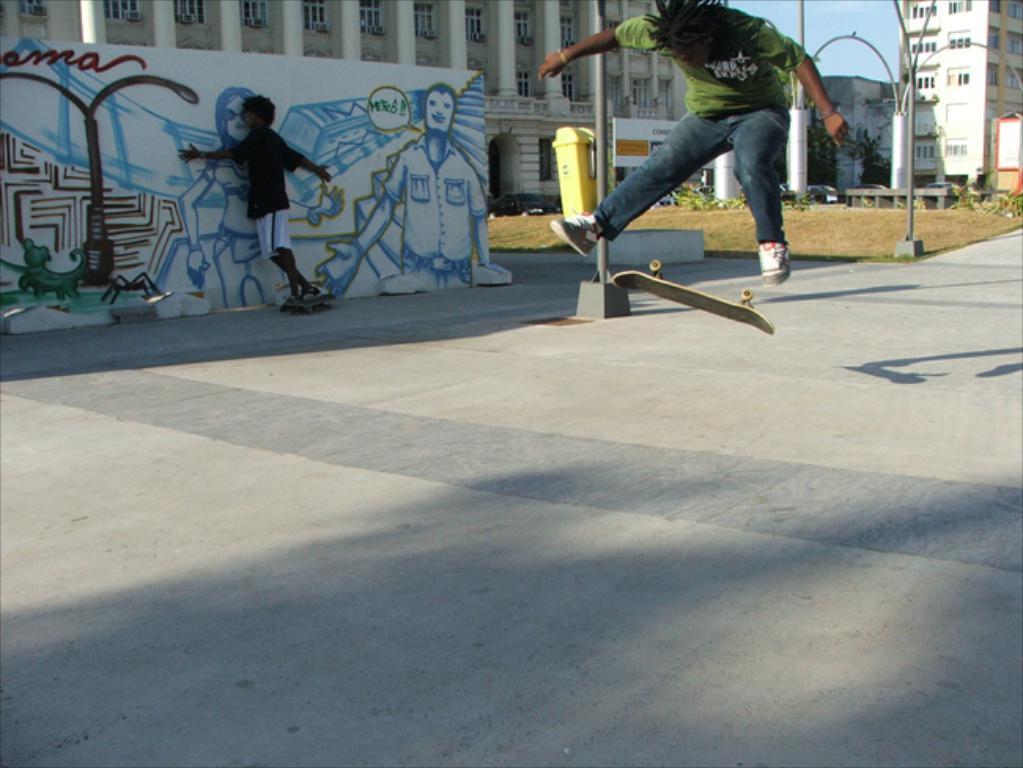How would you summarize this image in a sentence or two? In the middle of the image two persons are doing skating. Behind them we can see some poles, banner, plants and buildings. 